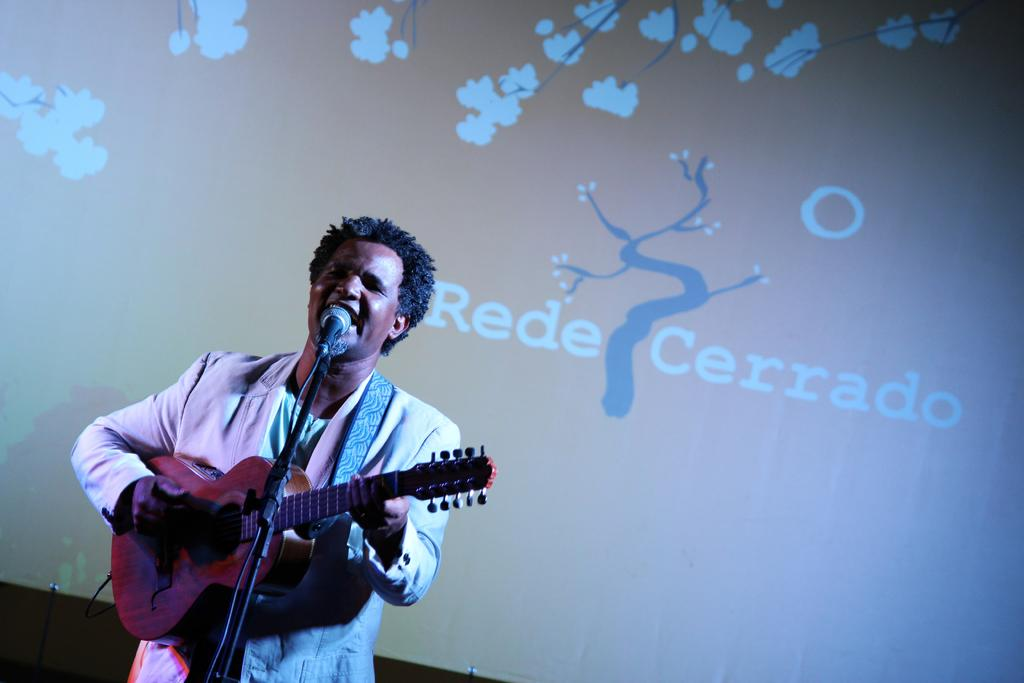What is the person in the image doing? The person is playing a guitar. Can you describe the person's activity in the image? The person is standing and playing a guitar. What can be seen in the background of the image? There is a banner visible in the background of the image. What year is depicted on the zipper of the person's clothing in the image? There is no zipper visible on the person's clothing in the image. What type of connection can be seen between the person and the guitar in the image? The person is playing the guitar, which implies a connection through their hands and fingers, but there is no visible connection like a cable or strap. 